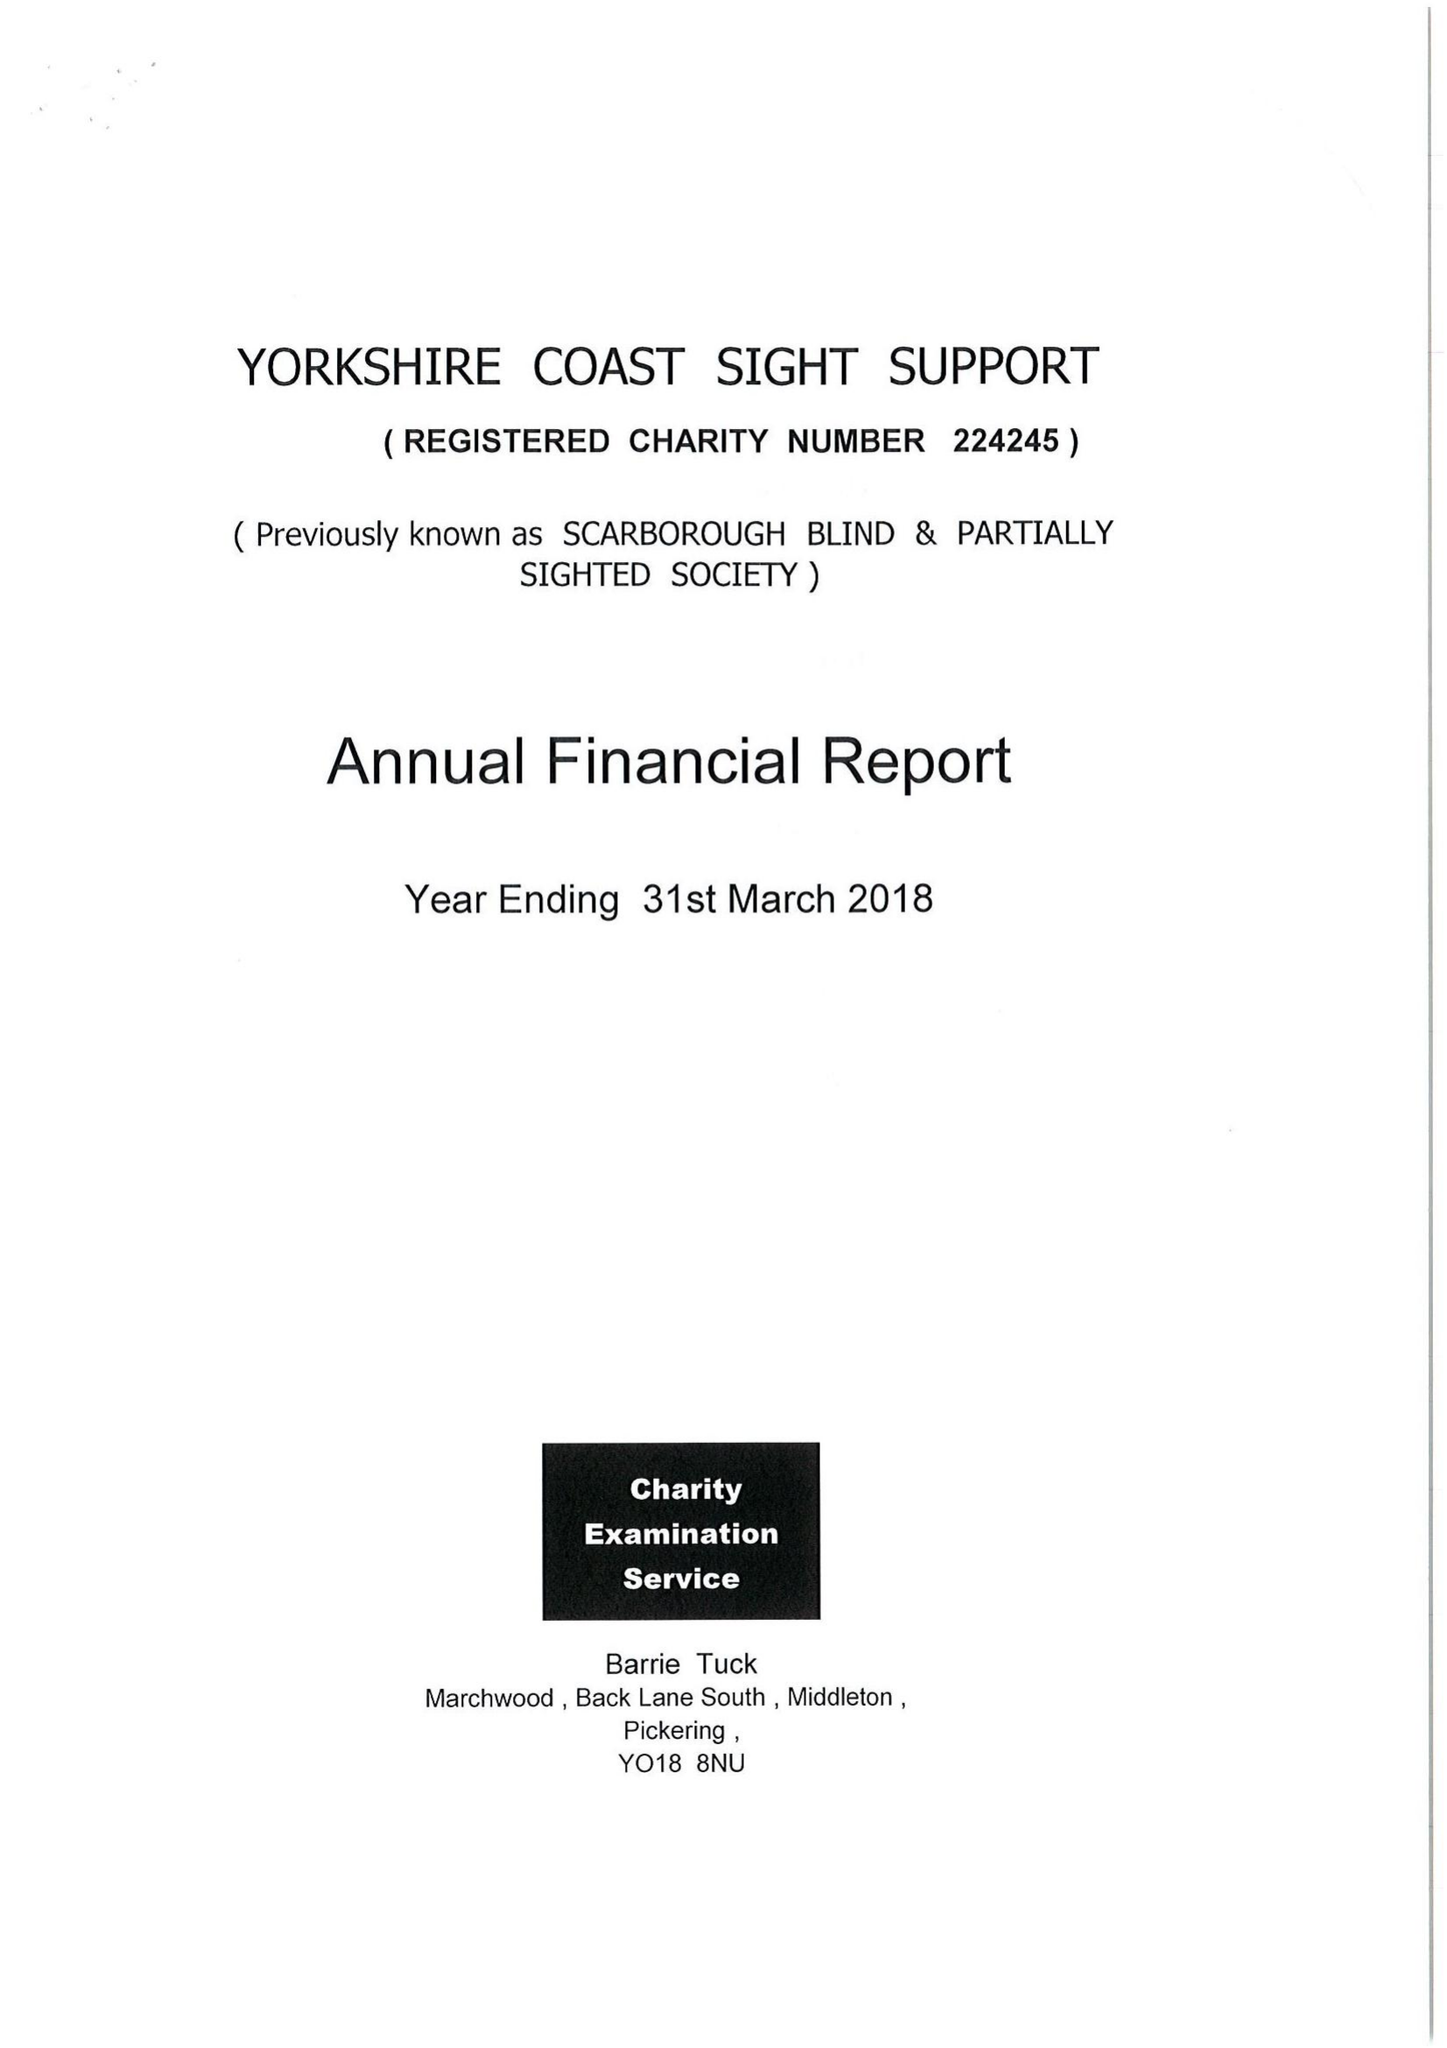What is the value for the charity_number?
Answer the question using a single word or phrase. 224245 